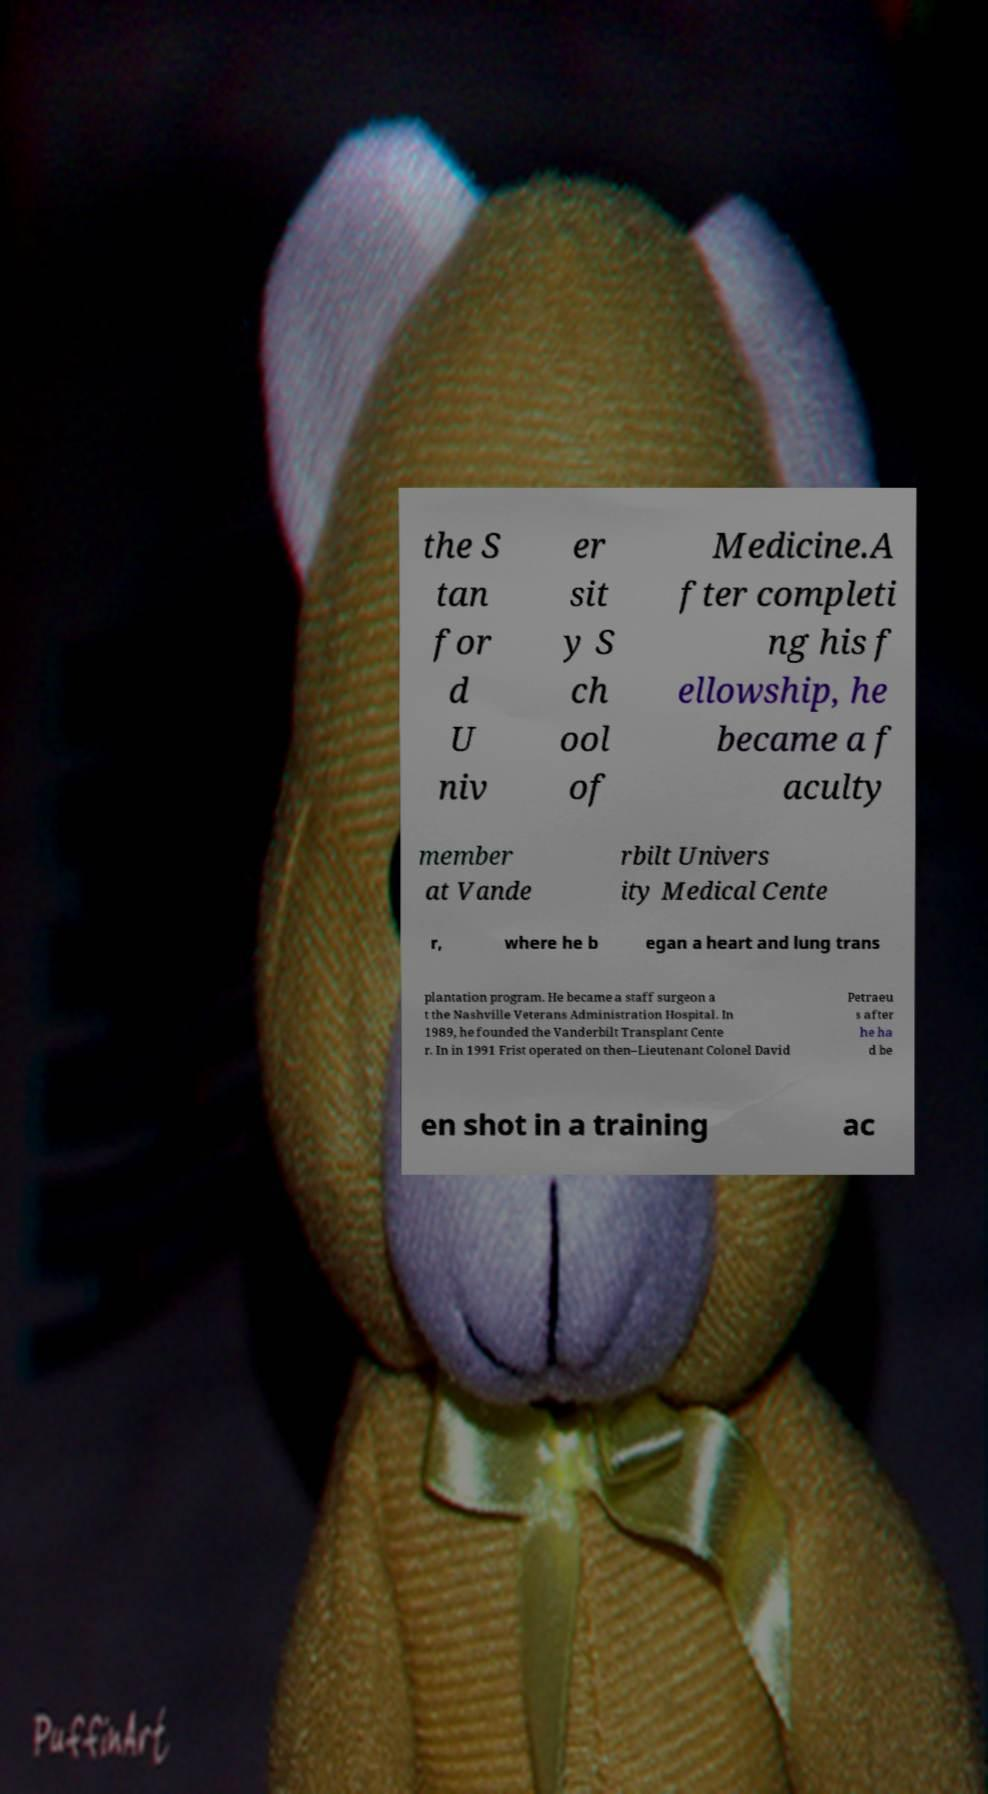Please read and relay the text visible in this image. What does it say? the S tan for d U niv er sit y S ch ool of Medicine.A fter completi ng his f ellowship, he became a f aculty member at Vande rbilt Univers ity Medical Cente r, where he b egan a heart and lung trans plantation program. He became a staff surgeon a t the Nashville Veterans Administration Hospital. In 1989, he founded the Vanderbilt Transplant Cente r. In in 1991 Frist operated on then–Lieutenant Colonel David Petraeu s after he ha d be en shot in a training ac 